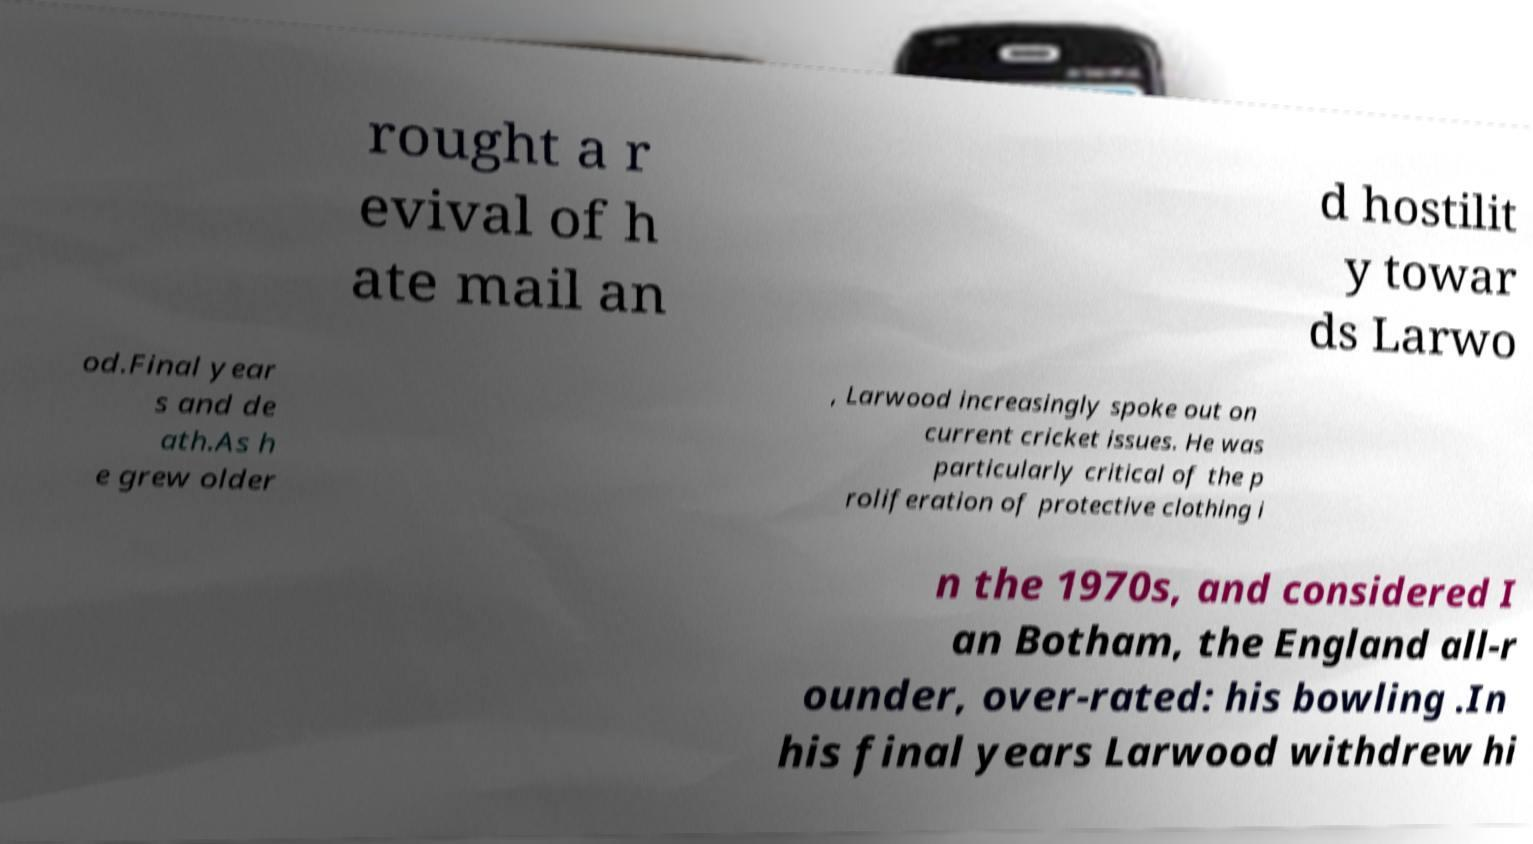Can you read and provide the text displayed in the image?This photo seems to have some interesting text. Can you extract and type it out for me? rought a r evival of h ate mail an d hostilit y towar ds Larwo od.Final year s and de ath.As h e grew older , Larwood increasingly spoke out on current cricket issues. He was particularly critical of the p roliferation of protective clothing i n the 1970s, and considered I an Botham, the England all-r ounder, over-rated: his bowling .In his final years Larwood withdrew hi 